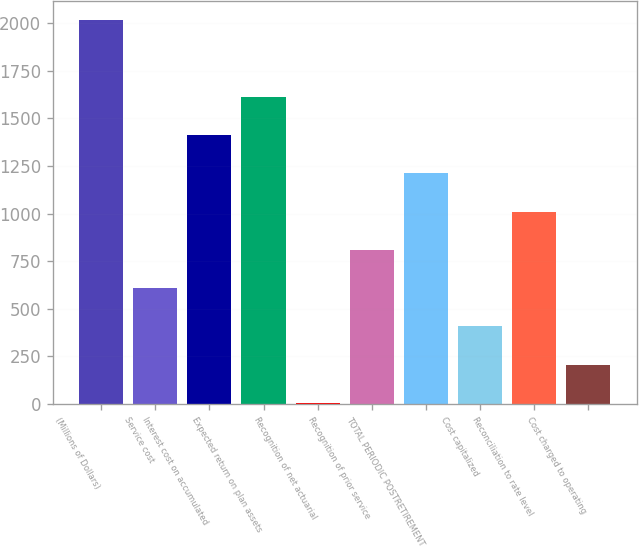Convert chart to OTSL. <chart><loc_0><loc_0><loc_500><loc_500><bar_chart><fcel>(Millions of Dollars)<fcel>Service cost<fcel>Interest cost on accumulated<fcel>Expected return on plan assets<fcel>Recognition of net actuarial<fcel>Recognition of prior service<fcel>TOTAL PERIODIC POSTRETIREMENT<fcel>Cost capitalized<fcel>Reconciliation to rate level<fcel>Cost charged to operating<nl><fcel>2016<fcel>608.3<fcel>1412.7<fcel>1613.8<fcel>5<fcel>809.4<fcel>1211.6<fcel>407.2<fcel>1010.5<fcel>206.1<nl></chart> 